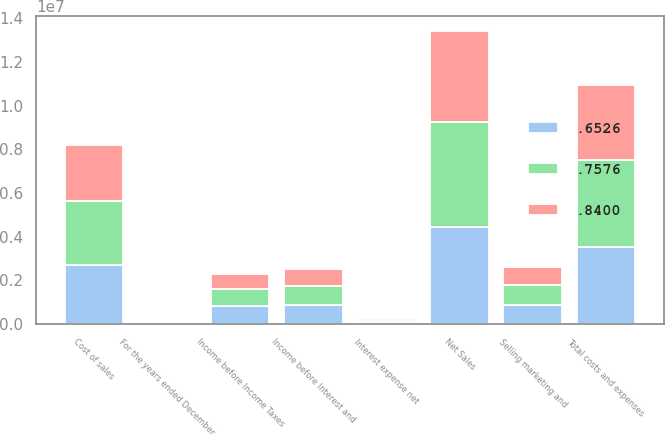Convert chart. <chart><loc_0><loc_0><loc_500><loc_500><stacked_bar_chart><ecel><fcel>For the years ended December<fcel>Net Sales<fcel>Cost of sales<fcel>Selling marketing and<fcel>Total costs and expenses<fcel>Income before Interest and<fcel>Interest expense net<fcel>Income before Income Taxes<nl><fcel>0.7576<fcel>2005<fcel>4.83597e+06<fcel>2.96554e+06<fcel>912986<fcel>3.97506e+06<fcel>860911<fcel>87985<fcel>772926<nl><fcel>0.6526<fcel>2004<fcel>4.42925e+06<fcel>2.68044e+06<fcel>867104<fcel>3.54754e+06<fcel>881707<fcel>66533<fcel>815174<nl><fcel>0.84<fcel>2003<fcel>4.17255e+06<fcel>2.54473e+06<fcel>841105<fcel>3.40086e+06<fcel>771693<fcel>63529<fcel>708164<nl></chart> 